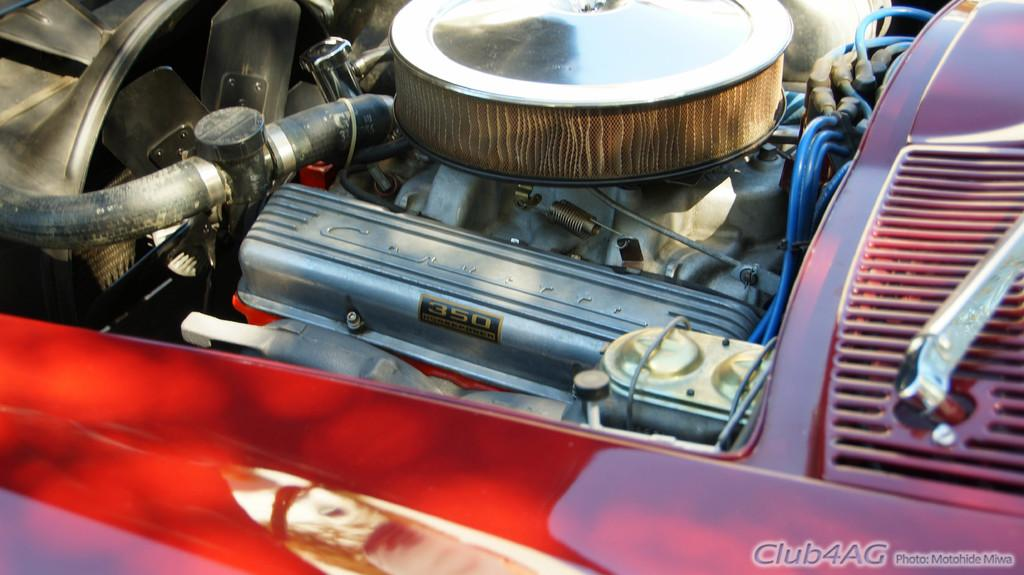What is the main subject of the image? The main subject of the image is an engine of a car. Where is the engine located in the image? The engine is in the middle of the image. Is there any additional information or marking present in the image? Yes, there is a watermark at the bottom of the image. How does the engine express love in the image? The engine does not express love in the image, as it is an inanimate object and cannot experience emotions. 